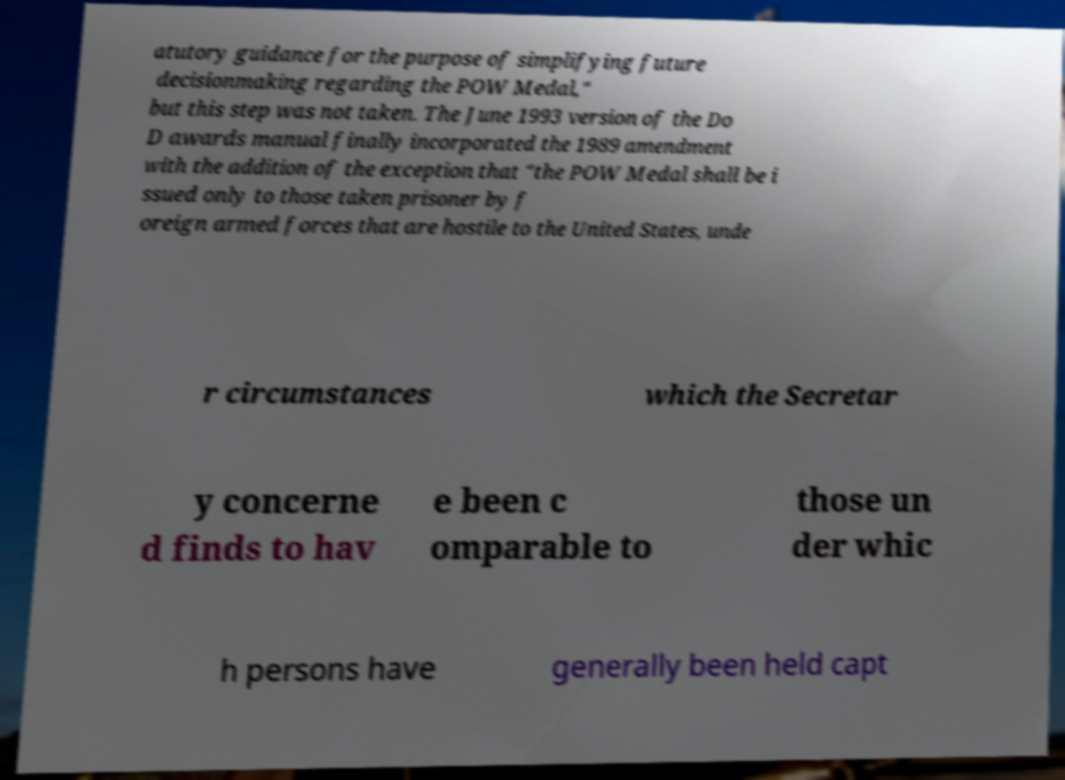Please read and relay the text visible in this image. What does it say? atutory guidance for the purpose of simplifying future decisionmaking regarding the POW Medal," but this step was not taken. The June 1993 version of the Do D awards manual finally incorporated the 1989 amendment with the addition of the exception that "the POW Medal shall be i ssued only to those taken prisoner by f oreign armed forces that are hostile to the United States, unde r circumstances which the Secretar y concerne d finds to hav e been c omparable to those un der whic h persons have generally been held capt 